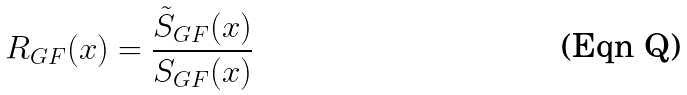<formula> <loc_0><loc_0><loc_500><loc_500>R _ { G F } ( x ) = \frac { \tilde { S } _ { G F } ( x ) } { S _ { G F } ( x ) }</formula> 